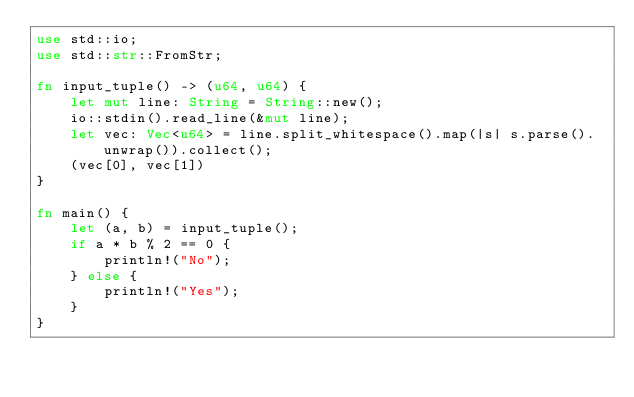<code> <loc_0><loc_0><loc_500><loc_500><_Rust_>use std::io;
use std::str::FromStr;

fn input_tuple() -> (u64, u64) {
    let mut line: String = String::new();
    io::stdin().read_line(&mut line);
    let vec: Vec<u64> = line.split_whitespace().map(|s| s.parse().unwrap()).collect();
    (vec[0], vec[1])
}

fn main() {
    let (a, b) = input_tuple();
    if a * b % 2 == 0 {
        println!("No");
    } else {
        println!("Yes");
    }
}
</code> 